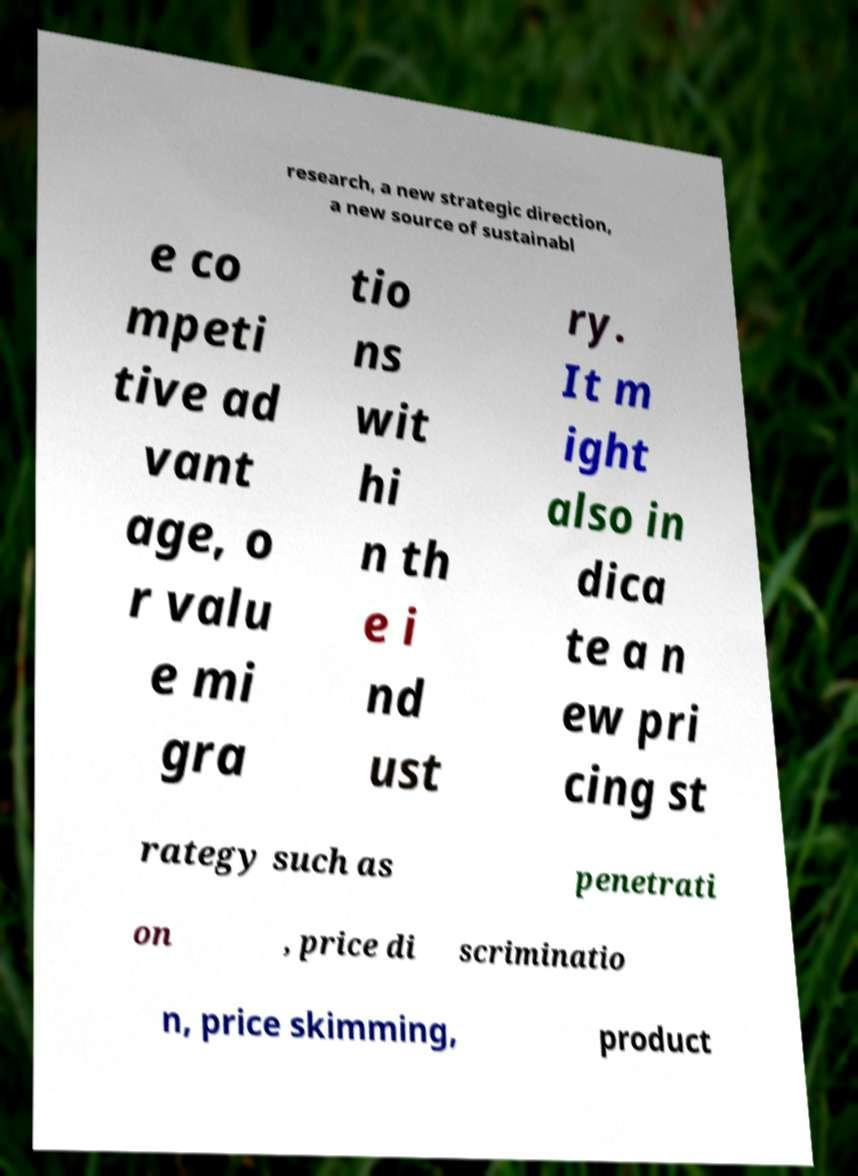Can you accurately transcribe the text from the provided image for me? research, a new strategic direction, a new source of sustainabl e co mpeti tive ad vant age, o r valu e mi gra tio ns wit hi n th e i nd ust ry. It m ight also in dica te a n ew pri cing st rategy such as penetrati on , price di scriminatio n, price skimming, product 